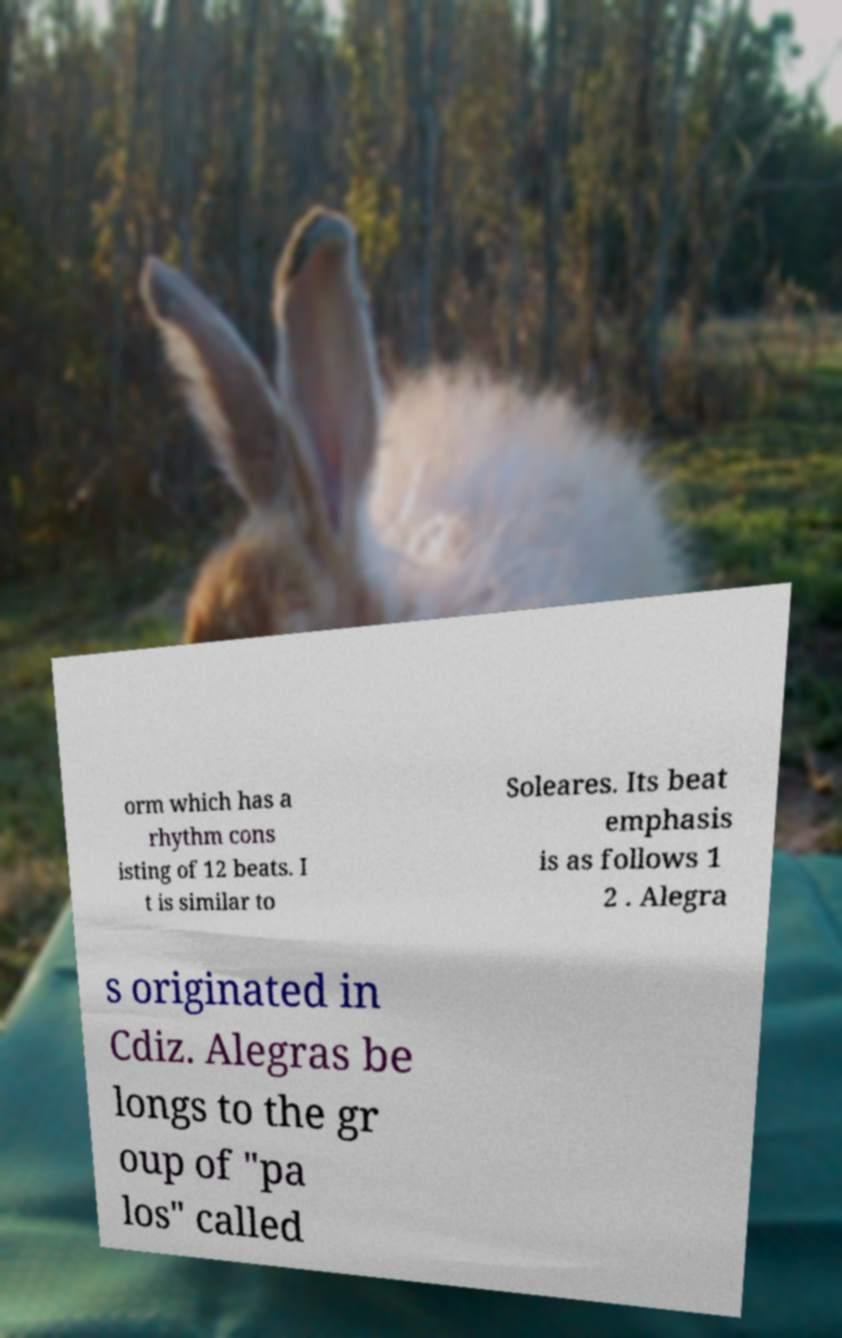There's text embedded in this image that I need extracted. Can you transcribe it verbatim? orm which has a rhythm cons isting of 12 beats. I t is similar to Soleares. Its beat emphasis is as follows 1 2 . Alegra s originated in Cdiz. Alegras be longs to the gr oup of "pa los" called 